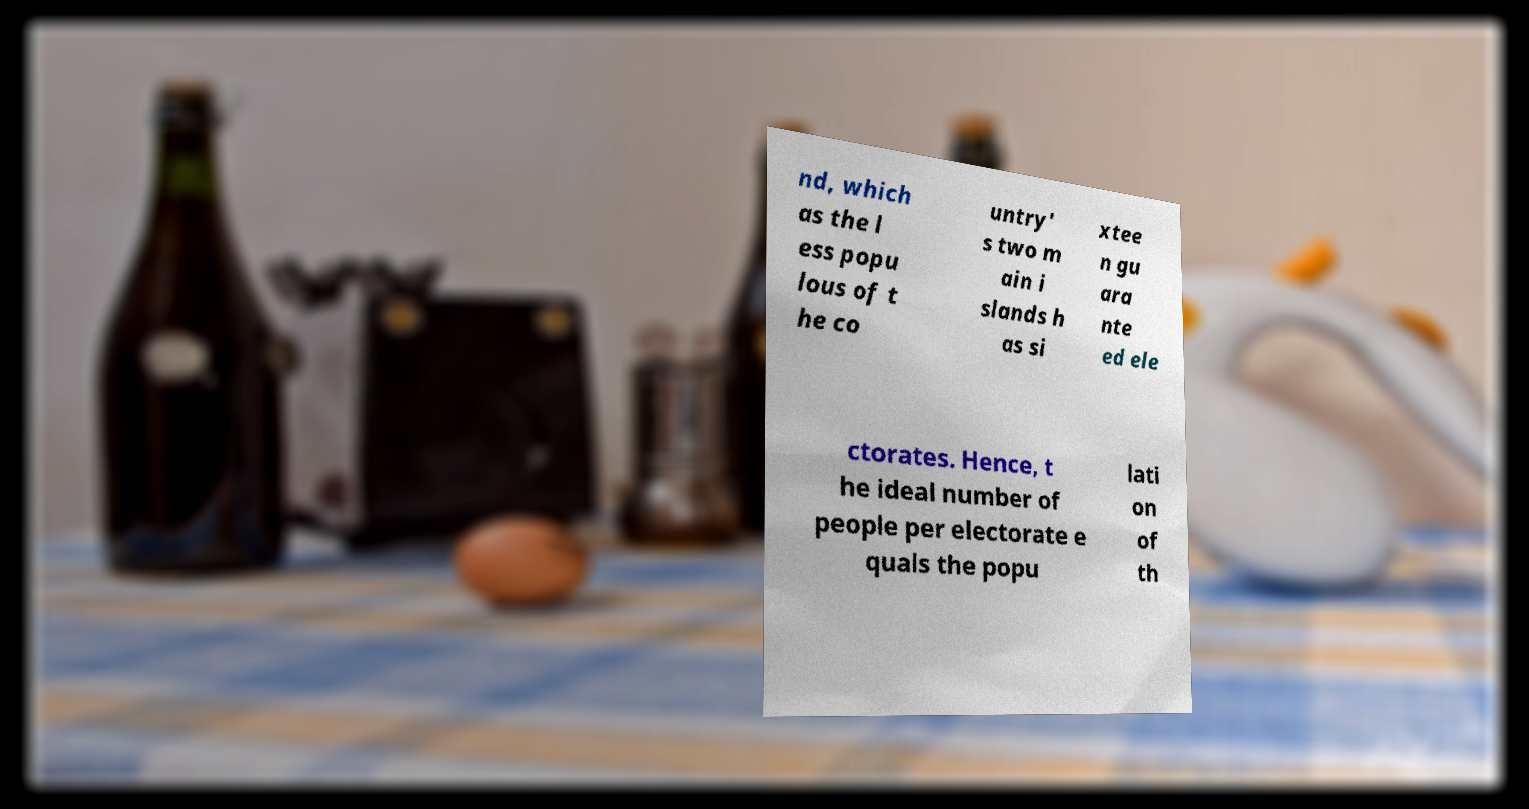Could you assist in decoding the text presented in this image and type it out clearly? nd, which as the l ess popu lous of t he co untry' s two m ain i slands h as si xtee n gu ara nte ed ele ctorates. Hence, t he ideal number of people per electorate e quals the popu lati on of th 